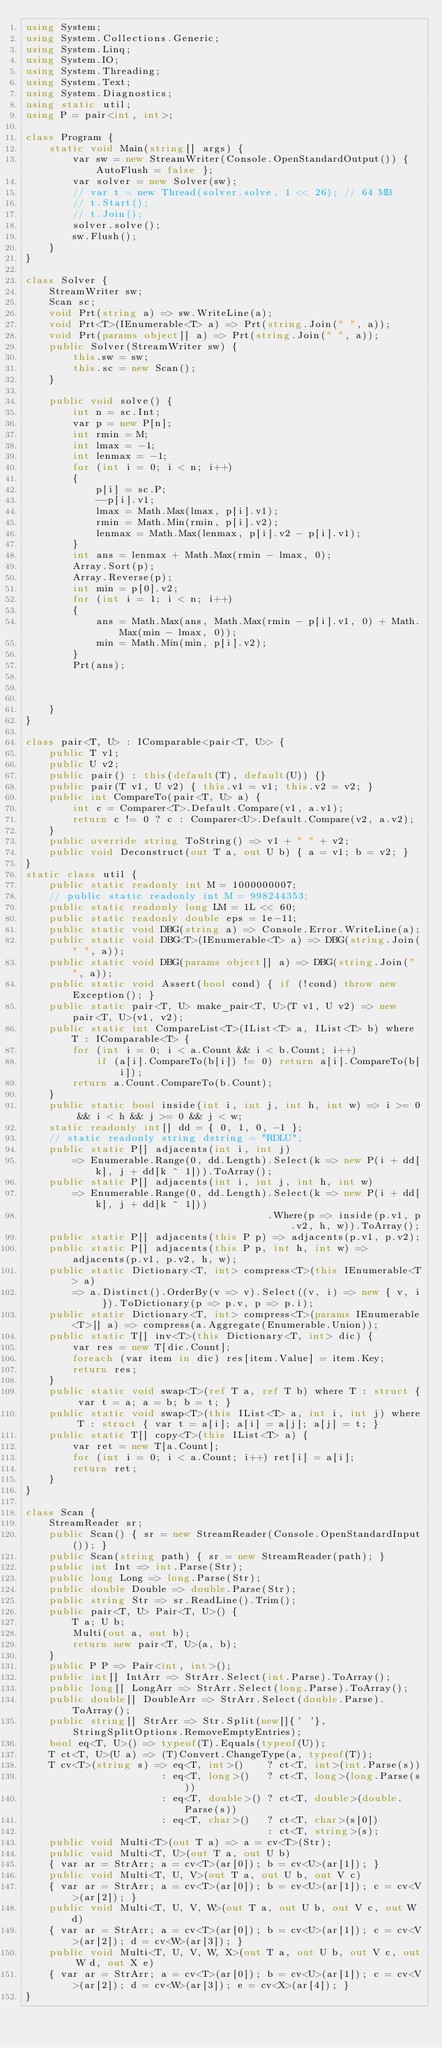<code> <loc_0><loc_0><loc_500><loc_500><_C#_>using System;
using System.Collections.Generic;
using System.Linq;
using System.IO;
using System.Threading;
using System.Text;
using System.Diagnostics;
using static util;
using P = pair<int, int>;

class Program {
    static void Main(string[] args) {
        var sw = new StreamWriter(Console.OpenStandardOutput()) { AutoFlush = false };
        var solver = new Solver(sw);
        // var t = new Thread(solver.solve, 1 << 26); // 64 MB
        // t.Start();
        // t.Join();
        solver.solve();
        sw.Flush();
    }
}

class Solver {
    StreamWriter sw;
    Scan sc;
    void Prt(string a) => sw.WriteLine(a);
    void Prt<T>(IEnumerable<T> a) => Prt(string.Join(" ", a));
    void Prt(params object[] a) => Prt(string.Join(" ", a));
    public Solver(StreamWriter sw) {
        this.sw = sw;
        this.sc = new Scan();
    }

    public void solve() {
        int n = sc.Int;
        var p = new P[n];
        int rmin = M;
        int lmax = -1;
        int lenmax = -1;
        for (int i = 0; i < n; i++)
        {
            p[i] = sc.P;
            --p[i].v1;
            lmax = Math.Max(lmax, p[i].v1);
            rmin = Math.Min(rmin, p[i].v2);
            lenmax = Math.Max(lenmax, p[i].v2 - p[i].v1);
        }
        int ans = lenmax + Math.Max(rmin - lmax, 0);
        Array.Sort(p);
        Array.Reverse(p);
        int min = p[0].v2;
        for (int i = 1; i < n; i++)
        {
            ans = Math.Max(ans, Math.Max(rmin - p[i].v1, 0) + Math.Max(min - lmax, 0));
            min = Math.Min(min, p[i].v2);
        }
        Prt(ans);



    }
}

class pair<T, U> : IComparable<pair<T, U>> {
    public T v1;
    public U v2;
    public pair() : this(default(T), default(U)) {}
    public pair(T v1, U v2) { this.v1 = v1; this.v2 = v2; }
    public int CompareTo(pair<T, U> a) {
        int c = Comparer<T>.Default.Compare(v1, a.v1);
        return c != 0 ? c : Comparer<U>.Default.Compare(v2, a.v2);
    }
    public override string ToString() => v1 + " " + v2;
    public void Deconstruct(out T a, out U b) { a = v1; b = v2; }
}
static class util {
    public static readonly int M = 1000000007;
    // public static readonly int M = 998244353;
    public static readonly long LM = 1L << 60;
    public static readonly double eps = 1e-11;
    public static void DBG(string a) => Console.Error.WriteLine(a);
    public static void DBG<T>(IEnumerable<T> a) => DBG(string.Join(" ", a));
    public static void DBG(params object[] a) => DBG(string.Join(" ", a));
    public static void Assert(bool cond) { if (!cond) throw new Exception(); }
    public static pair<T, U> make_pair<T, U>(T v1, U v2) => new pair<T, U>(v1, v2);
    public static int CompareList<T>(IList<T> a, IList<T> b) where T : IComparable<T> {
        for (int i = 0; i < a.Count && i < b.Count; i++)
            if (a[i].CompareTo(b[i]) != 0) return a[i].CompareTo(b[i]);
        return a.Count.CompareTo(b.Count);
    }
    public static bool inside(int i, int j, int h, int w) => i >= 0 && i < h && j >= 0 && j < w;
    static readonly int[] dd = { 0, 1, 0, -1 };
    // static readonly string dstring = "RDLU";
    public static P[] adjacents(int i, int j)
        => Enumerable.Range(0, dd.Length).Select(k => new P(i + dd[k], j + dd[k ^ 1])).ToArray();
    public static P[] adjacents(int i, int j, int h, int w)
        => Enumerable.Range(0, dd.Length).Select(k => new P(i + dd[k], j + dd[k ^ 1]))
                                         .Where(p => inside(p.v1, p.v2, h, w)).ToArray();
    public static P[] adjacents(this P p) => adjacents(p.v1, p.v2);
    public static P[] adjacents(this P p, int h, int w) => adjacents(p.v1, p.v2, h, w);
    public static Dictionary<T, int> compress<T>(this IEnumerable<T> a)
        => a.Distinct().OrderBy(v => v).Select((v, i) => new { v, i }).ToDictionary(p => p.v, p => p.i);
    public static Dictionary<T, int> compress<T>(params IEnumerable<T>[] a) => compress(a.Aggregate(Enumerable.Union));
    public static T[] inv<T>(this Dictionary<T, int> dic) {
        var res = new T[dic.Count];
        foreach (var item in dic) res[item.Value] = item.Key;
        return res;
    }
    public static void swap<T>(ref T a, ref T b) where T : struct { var t = a; a = b; b = t; }
    public static void swap<T>(this IList<T> a, int i, int j) where T : struct { var t = a[i]; a[i] = a[j]; a[j] = t; }
    public static T[] copy<T>(this IList<T> a) {
        var ret = new T[a.Count];
        for (int i = 0; i < a.Count; i++) ret[i] = a[i];
        return ret;
    }
}

class Scan {
    StreamReader sr;
    public Scan() { sr = new StreamReader(Console.OpenStandardInput()); }
    public Scan(string path) { sr = new StreamReader(path); }
    public int Int => int.Parse(Str);
    public long Long => long.Parse(Str);
    public double Double => double.Parse(Str);
    public string Str => sr.ReadLine().Trim();
    public pair<T, U> Pair<T, U>() {
        T a; U b;
        Multi(out a, out b);
        return new pair<T, U>(a, b);
    }
    public P P => Pair<int, int>();
    public int[] IntArr => StrArr.Select(int.Parse).ToArray();
    public long[] LongArr => StrArr.Select(long.Parse).ToArray();
    public double[] DoubleArr => StrArr.Select(double.Parse).ToArray();
    public string[] StrArr => Str.Split(new[]{' '}, StringSplitOptions.RemoveEmptyEntries);
    bool eq<T, U>() => typeof(T).Equals(typeof(U));
    T ct<T, U>(U a) => (T)Convert.ChangeType(a, typeof(T));
    T cv<T>(string s) => eq<T, int>()    ? ct<T, int>(int.Parse(s))
                       : eq<T, long>()   ? ct<T, long>(long.Parse(s))
                       : eq<T, double>() ? ct<T, double>(double.Parse(s))
                       : eq<T, char>()   ? ct<T, char>(s[0])
                                         : ct<T, string>(s);
    public void Multi<T>(out T a) => a = cv<T>(Str);
    public void Multi<T, U>(out T a, out U b)
    { var ar = StrArr; a = cv<T>(ar[0]); b = cv<U>(ar[1]); }
    public void Multi<T, U, V>(out T a, out U b, out V c)
    { var ar = StrArr; a = cv<T>(ar[0]); b = cv<U>(ar[1]); c = cv<V>(ar[2]); }
    public void Multi<T, U, V, W>(out T a, out U b, out V c, out W d)
    { var ar = StrArr; a = cv<T>(ar[0]); b = cv<U>(ar[1]); c = cv<V>(ar[2]); d = cv<W>(ar[3]); }
    public void Multi<T, U, V, W, X>(out T a, out U b, out V c, out W d, out X e)
    { var ar = StrArr; a = cv<T>(ar[0]); b = cv<U>(ar[1]); c = cv<V>(ar[2]); d = cv<W>(ar[3]); e = cv<X>(ar[4]); }
}
</code> 